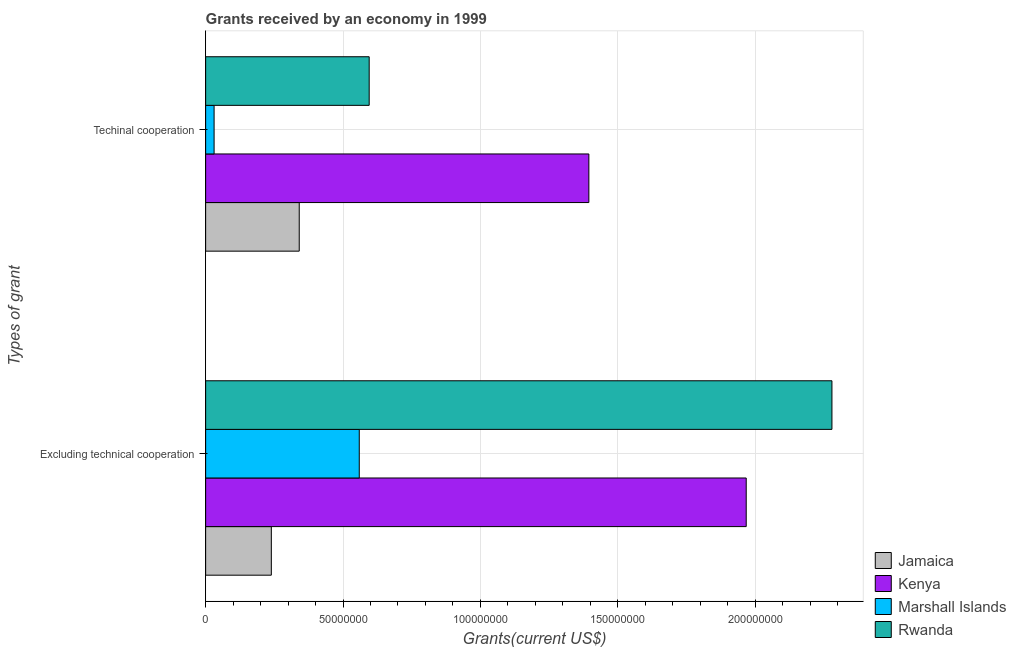Are the number of bars per tick equal to the number of legend labels?
Offer a very short reply. Yes. Are the number of bars on each tick of the Y-axis equal?
Ensure brevity in your answer.  Yes. What is the label of the 1st group of bars from the top?
Your answer should be compact. Techinal cooperation. What is the amount of grants received(excluding technical cooperation) in Marshall Islands?
Make the answer very short. 5.59e+07. Across all countries, what is the maximum amount of grants received(excluding technical cooperation)?
Offer a terse response. 2.28e+08. Across all countries, what is the minimum amount of grants received(including technical cooperation)?
Your answer should be very brief. 3.08e+06. In which country was the amount of grants received(excluding technical cooperation) maximum?
Offer a terse response. Rwanda. In which country was the amount of grants received(including technical cooperation) minimum?
Keep it short and to the point. Marshall Islands. What is the total amount of grants received(including technical cooperation) in the graph?
Offer a very short reply. 2.36e+08. What is the difference between the amount of grants received(including technical cooperation) in Marshall Islands and that in Jamaica?
Your answer should be compact. -3.10e+07. What is the difference between the amount of grants received(excluding technical cooperation) in Kenya and the amount of grants received(including technical cooperation) in Rwanda?
Keep it short and to the point. 1.37e+08. What is the average amount of grants received(including technical cooperation) per country?
Offer a terse response. 5.90e+07. What is the difference between the amount of grants received(excluding technical cooperation) and amount of grants received(including technical cooperation) in Rwanda?
Offer a terse response. 1.68e+08. In how many countries, is the amount of grants received(including technical cooperation) greater than 140000000 US$?
Offer a very short reply. 0. What is the ratio of the amount of grants received(excluding technical cooperation) in Kenya to that in Rwanda?
Provide a short and direct response. 0.86. Is the amount of grants received(excluding technical cooperation) in Kenya less than that in Jamaica?
Offer a very short reply. No. What does the 4th bar from the top in Excluding technical cooperation represents?
Offer a terse response. Jamaica. What does the 3rd bar from the bottom in Techinal cooperation represents?
Keep it short and to the point. Marshall Islands. How many bars are there?
Give a very brief answer. 8. Are all the bars in the graph horizontal?
Offer a terse response. Yes. How many countries are there in the graph?
Offer a very short reply. 4. Where does the legend appear in the graph?
Your answer should be compact. Bottom right. What is the title of the graph?
Make the answer very short. Grants received by an economy in 1999. Does "Jordan" appear as one of the legend labels in the graph?
Offer a very short reply. No. What is the label or title of the X-axis?
Your answer should be compact. Grants(current US$). What is the label or title of the Y-axis?
Your response must be concise. Types of grant. What is the Grants(current US$) of Jamaica in Excluding technical cooperation?
Give a very brief answer. 2.39e+07. What is the Grants(current US$) in Kenya in Excluding technical cooperation?
Keep it short and to the point. 1.97e+08. What is the Grants(current US$) of Marshall Islands in Excluding technical cooperation?
Make the answer very short. 5.59e+07. What is the Grants(current US$) in Rwanda in Excluding technical cooperation?
Keep it short and to the point. 2.28e+08. What is the Grants(current US$) of Jamaica in Techinal cooperation?
Provide a succinct answer. 3.41e+07. What is the Grants(current US$) in Kenya in Techinal cooperation?
Offer a very short reply. 1.39e+08. What is the Grants(current US$) of Marshall Islands in Techinal cooperation?
Give a very brief answer. 3.08e+06. What is the Grants(current US$) of Rwanda in Techinal cooperation?
Make the answer very short. 5.95e+07. Across all Types of grant, what is the maximum Grants(current US$) of Jamaica?
Keep it short and to the point. 3.41e+07. Across all Types of grant, what is the maximum Grants(current US$) of Kenya?
Give a very brief answer. 1.97e+08. Across all Types of grant, what is the maximum Grants(current US$) of Marshall Islands?
Provide a short and direct response. 5.59e+07. Across all Types of grant, what is the maximum Grants(current US$) in Rwanda?
Your answer should be compact. 2.28e+08. Across all Types of grant, what is the minimum Grants(current US$) of Jamaica?
Your answer should be very brief. 2.39e+07. Across all Types of grant, what is the minimum Grants(current US$) of Kenya?
Ensure brevity in your answer.  1.39e+08. Across all Types of grant, what is the minimum Grants(current US$) in Marshall Islands?
Keep it short and to the point. 3.08e+06. Across all Types of grant, what is the minimum Grants(current US$) in Rwanda?
Ensure brevity in your answer.  5.95e+07. What is the total Grants(current US$) in Jamaica in the graph?
Your response must be concise. 5.80e+07. What is the total Grants(current US$) of Kenya in the graph?
Offer a terse response. 3.36e+08. What is the total Grants(current US$) in Marshall Islands in the graph?
Your answer should be compact. 5.90e+07. What is the total Grants(current US$) of Rwanda in the graph?
Offer a terse response. 2.88e+08. What is the difference between the Grants(current US$) in Jamaica in Excluding technical cooperation and that in Techinal cooperation?
Ensure brevity in your answer.  -1.02e+07. What is the difference between the Grants(current US$) of Kenya in Excluding technical cooperation and that in Techinal cooperation?
Keep it short and to the point. 5.73e+07. What is the difference between the Grants(current US$) in Marshall Islands in Excluding technical cooperation and that in Techinal cooperation?
Ensure brevity in your answer.  5.28e+07. What is the difference between the Grants(current US$) in Rwanda in Excluding technical cooperation and that in Techinal cooperation?
Provide a succinct answer. 1.68e+08. What is the difference between the Grants(current US$) of Jamaica in Excluding technical cooperation and the Grants(current US$) of Kenya in Techinal cooperation?
Ensure brevity in your answer.  -1.16e+08. What is the difference between the Grants(current US$) in Jamaica in Excluding technical cooperation and the Grants(current US$) in Marshall Islands in Techinal cooperation?
Ensure brevity in your answer.  2.08e+07. What is the difference between the Grants(current US$) in Jamaica in Excluding technical cooperation and the Grants(current US$) in Rwanda in Techinal cooperation?
Keep it short and to the point. -3.56e+07. What is the difference between the Grants(current US$) in Kenya in Excluding technical cooperation and the Grants(current US$) in Marshall Islands in Techinal cooperation?
Your answer should be compact. 1.94e+08. What is the difference between the Grants(current US$) in Kenya in Excluding technical cooperation and the Grants(current US$) in Rwanda in Techinal cooperation?
Offer a very short reply. 1.37e+08. What is the difference between the Grants(current US$) of Marshall Islands in Excluding technical cooperation and the Grants(current US$) of Rwanda in Techinal cooperation?
Ensure brevity in your answer.  -3.61e+06. What is the average Grants(current US$) of Jamaica per Types of grant?
Offer a very short reply. 2.90e+07. What is the average Grants(current US$) of Kenya per Types of grant?
Keep it short and to the point. 1.68e+08. What is the average Grants(current US$) of Marshall Islands per Types of grant?
Offer a terse response. 2.95e+07. What is the average Grants(current US$) in Rwanda per Types of grant?
Make the answer very short. 1.44e+08. What is the difference between the Grants(current US$) of Jamaica and Grants(current US$) of Kenya in Excluding technical cooperation?
Your response must be concise. -1.73e+08. What is the difference between the Grants(current US$) of Jamaica and Grants(current US$) of Marshall Islands in Excluding technical cooperation?
Offer a terse response. -3.20e+07. What is the difference between the Grants(current US$) in Jamaica and Grants(current US$) in Rwanda in Excluding technical cooperation?
Ensure brevity in your answer.  -2.04e+08. What is the difference between the Grants(current US$) in Kenya and Grants(current US$) in Marshall Islands in Excluding technical cooperation?
Make the answer very short. 1.41e+08. What is the difference between the Grants(current US$) of Kenya and Grants(current US$) of Rwanda in Excluding technical cooperation?
Provide a short and direct response. -3.12e+07. What is the difference between the Grants(current US$) of Marshall Islands and Grants(current US$) of Rwanda in Excluding technical cooperation?
Offer a very short reply. -1.72e+08. What is the difference between the Grants(current US$) of Jamaica and Grants(current US$) of Kenya in Techinal cooperation?
Offer a terse response. -1.05e+08. What is the difference between the Grants(current US$) of Jamaica and Grants(current US$) of Marshall Islands in Techinal cooperation?
Ensure brevity in your answer.  3.10e+07. What is the difference between the Grants(current US$) in Jamaica and Grants(current US$) in Rwanda in Techinal cooperation?
Keep it short and to the point. -2.55e+07. What is the difference between the Grants(current US$) in Kenya and Grants(current US$) in Marshall Islands in Techinal cooperation?
Provide a succinct answer. 1.36e+08. What is the difference between the Grants(current US$) of Kenya and Grants(current US$) of Rwanda in Techinal cooperation?
Ensure brevity in your answer.  8.00e+07. What is the difference between the Grants(current US$) of Marshall Islands and Grants(current US$) of Rwanda in Techinal cooperation?
Keep it short and to the point. -5.64e+07. What is the ratio of the Grants(current US$) in Jamaica in Excluding technical cooperation to that in Techinal cooperation?
Your answer should be very brief. 0.7. What is the ratio of the Grants(current US$) in Kenya in Excluding technical cooperation to that in Techinal cooperation?
Offer a very short reply. 1.41. What is the ratio of the Grants(current US$) in Marshall Islands in Excluding technical cooperation to that in Techinal cooperation?
Keep it short and to the point. 18.16. What is the ratio of the Grants(current US$) of Rwanda in Excluding technical cooperation to that in Techinal cooperation?
Give a very brief answer. 3.83. What is the difference between the highest and the second highest Grants(current US$) of Jamaica?
Keep it short and to the point. 1.02e+07. What is the difference between the highest and the second highest Grants(current US$) of Kenya?
Your answer should be very brief. 5.73e+07. What is the difference between the highest and the second highest Grants(current US$) of Marshall Islands?
Keep it short and to the point. 5.28e+07. What is the difference between the highest and the second highest Grants(current US$) in Rwanda?
Offer a terse response. 1.68e+08. What is the difference between the highest and the lowest Grants(current US$) in Jamaica?
Give a very brief answer. 1.02e+07. What is the difference between the highest and the lowest Grants(current US$) of Kenya?
Provide a succinct answer. 5.73e+07. What is the difference between the highest and the lowest Grants(current US$) in Marshall Islands?
Ensure brevity in your answer.  5.28e+07. What is the difference between the highest and the lowest Grants(current US$) in Rwanda?
Make the answer very short. 1.68e+08. 